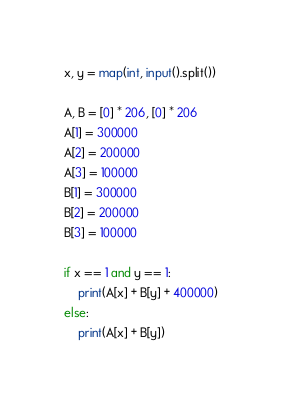<code> <loc_0><loc_0><loc_500><loc_500><_Python_>x, y = map(int, input().split())

A, B = [0] * 206, [0] * 206
A[1] = 300000
A[2] = 200000
A[3] = 100000
B[1] = 300000
B[2] = 200000
B[3] = 100000

if x == 1 and y == 1:
    print(A[x] + B[y] + 400000)
else:
    print(A[x] + B[y])</code> 